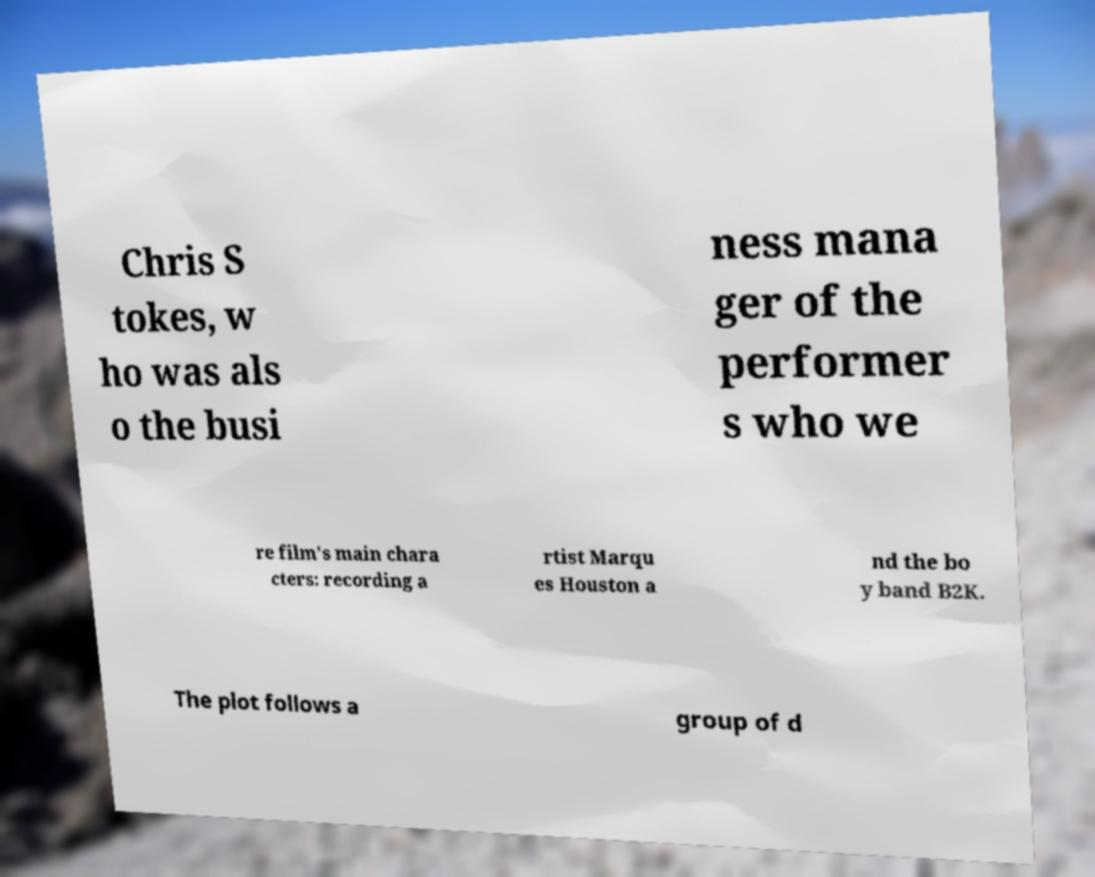Could you extract and type out the text from this image? Chris S tokes, w ho was als o the busi ness mana ger of the performer s who we re film's main chara cters: recording a rtist Marqu es Houston a nd the bo y band B2K. The plot follows a group of d 